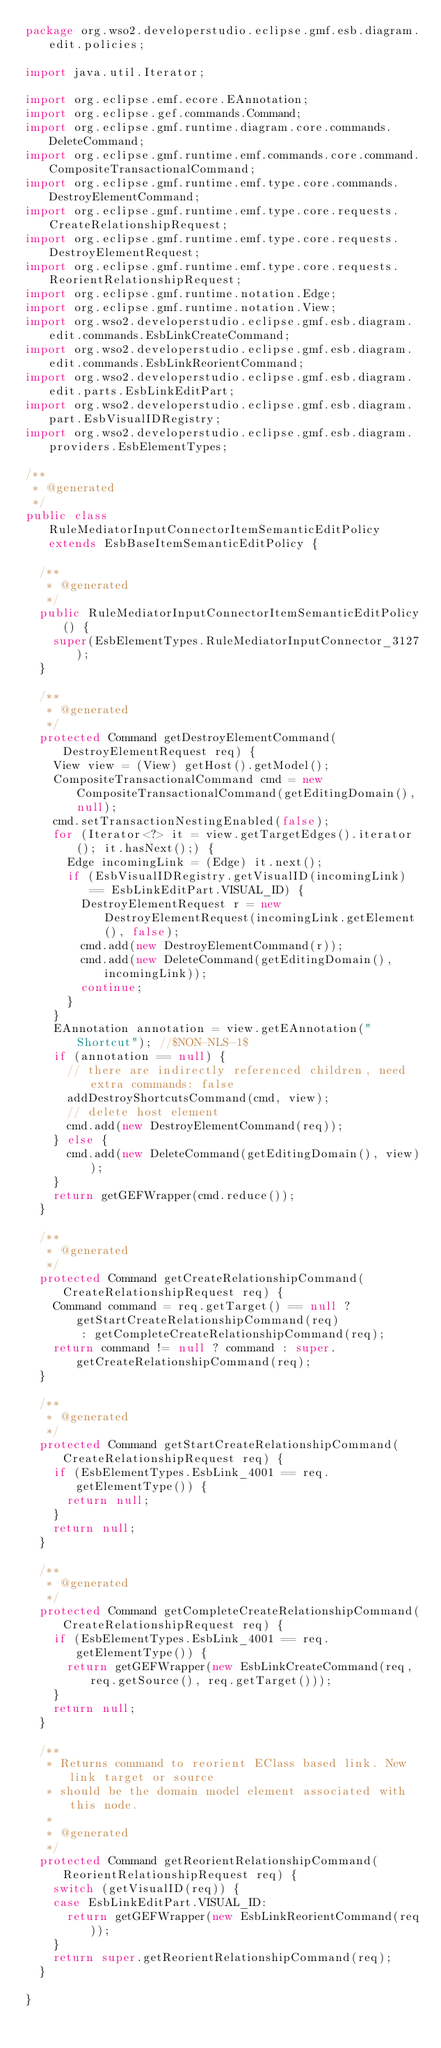Convert code to text. <code><loc_0><loc_0><loc_500><loc_500><_Java_>package org.wso2.developerstudio.eclipse.gmf.esb.diagram.edit.policies;

import java.util.Iterator;

import org.eclipse.emf.ecore.EAnnotation;
import org.eclipse.gef.commands.Command;
import org.eclipse.gmf.runtime.diagram.core.commands.DeleteCommand;
import org.eclipse.gmf.runtime.emf.commands.core.command.CompositeTransactionalCommand;
import org.eclipse.gmf.runtime.emf.type.core.commands.DestroyElementCommand;
import org.eclipse.gmf.runtime.emf.type.core.requests.CreateRelationshipRequest;
import org.eclipse.gmf.runtime.emf.type.core.requests.DestroyElementRequest;
import org.eclipse.gmf.runtime.emf.type.core.requests.ReorientRelationshipRequest;
import org.eclipse.gmf.runtime.notation.Edge;
import org.eclipse.gmf.runtime.notation.View;
import org.wso2.developerstudio.eclipse.gmf.esb.diagram.edit.commands.EsbLinkCreateCommand;
import org.wso2.developerstudio.eclipse.gmf.esb.diagram.edit.commands.EsbLinkReorientCommand;
import org.wso2.developerstudio.eclipse.gmf.esb.diagram.edit.parts.EsbLinkEditPart;
import org.wso2.developerstudio.eclipse.gmf.esb.diagram.part.EsbVisualIDRegistry;
import org.wso2.developerstudio.eclipse.gmf.esb.diagram.providers.EsbElementTypes;

/**
 * @generated
 */
public class RuleMediatorInputConnectorItemSemanticEditPolicy extends EsbBaseItemSemanticEditPolicy {

	/**
	 * @generated
	 */
	public RuleMediatorInputConnectorItemSemanticEditPolicy() {
		super(EsbElementTypes.RuleMediatorInputConnector_3127);
	}

	/**
	 * @generated
	 */
	protected Command getDestroyElementCommand(DestroyElementRequest req) {
		View view = (View) getHost().getModel();
		CompositeTransactionalCommand cmd = new CompositeTransactionalCommand(getEditingDomain(), null);
		cmd.setTransactionNestingEnabled(false);
		for (Iterator<?> it = view.getTargetEdges().iterator(); it.hasNext();) {
			Edge incomingLink = (Edge) it.next();
			if (EsbVisualIDRegistry.getVisualID(incomingLink) == EsbLinkEditPart.VISUAL_ID) {
				DestroyElementRequest r = new DestroyElementRequest(incomingLink.getElement(), false);
				cmd.add(new DestroyElementCommand(r));
				cmd.add(new DeleteCommand(getEditingDomain(), incomingLink));
				continue;
			}
		}
		EAnnotation annotation = view.getEAnnotation("Shortcut"); //$NON-NLS-1$
		if (annotation == null) {
			// there are indirectly referenced children, need extra commands: false
			addDestroyShortcutsCommand(cmd, view);
			// delete host element
			cmd.add(new DestroyElementCommand(req));
		} else {
			cmd.add(new DeleteCommand(getEditingDomain(), view));
		}
		return getGEFWrapper(cmd.reduce());
	}

	/**
	 * @generated
	 */
	protected Command getCreateRelationshipCommand(CreateRelationshipRequest req) {
		Command command = req.getTarget() == null ? getStartCreateRelationshipCommand(req)
				: getCompleteCreateRelationshipCommand(req);
		return command != null ? command : super.getCreateRelationshipCommand(req);
	}

	/**
	 * @generated
	 */
	protected Command getStartCreateRelationshipCommand(CreateRelationshipRequest req) {
		if (EsbElementTypes.EsbLink_4001 == req.getElementType()) {
			return null;
		}
		return null;
	}

	/**
	 * @generated
	 */
	protected Command getCompleteCreateRelationshipCommand(CreateRelationshipRequest req) {
		if (EsbElementTypes.EsbLink_4001 == req.getElementType()) {
			return getGEFWrapper(new EsbLinkCreateCommand(req, req.getSource(), req.getTarget()));
		}
		return null;
	}

	/**
	 * Returns command to reorient EClass based link. New link target or source
	 * should be the domain model element associated with this node.
	 * 
	 * @generated
	 */
	protected Command getReorientRelationshipCommand(ReorientRelationshipRequest req) {
		switch (getVisualID(req)) {
		case EsbLinkEditPart.VISUAL_ID:
			return getGEFWrapper(new EsbLinkReorientCommand(req));
		}
		return super.getReorientRelationshipCommand(req);
	}

}
</code> 